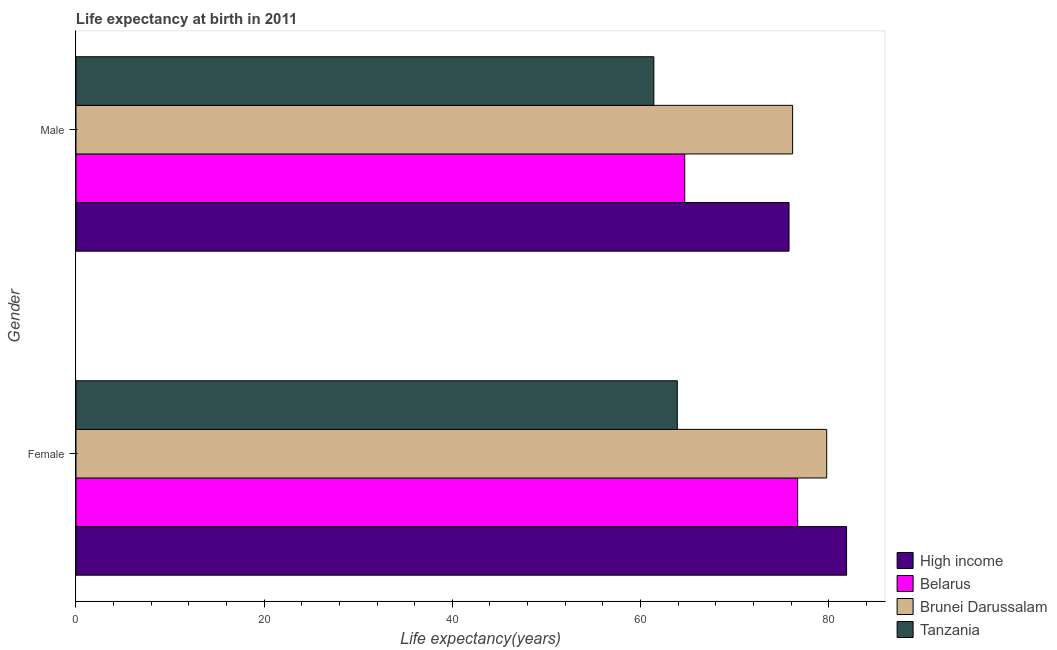How many different coloured bars are there?
Give a very brief answer. 4. How many groups of bars are there?
Offer a very short reply. 2. How many bars are there on the 1st tick from the top?
Provide a succinct answer. 4. What is the label of the 2nd group of bars from the top?
Your answer should be very brief. Female. What is the life expectancy(female) in Brunei Darussalam?
Make the answer very short. 79.79. Across all countries, what is the maximum life expectancy(female)?
Your answer should be very brief. 81.9. Across all countries, what is the minimum life expectancy(female)?
Offer a terse response. 63.91. In which country was the life expectancy(male) maximum?
Make the answer very short. Brunei Darussalam. In which country was the life expectancy(male) minimum?
Keep it short and to the point. Tanzania. What is the total life expectancy(female) in the graph?
Provide a short and direct response. 302.3. What is the difference between the life expectancy(male) in Brunei Darussalam and that in High income?
Your answer should be compact. 0.38. What is the difference between the life expectancy(female) in Belarus and the life expectancy(male) in Brunei Darussalam?
Ensure brevity in your answer.  0.53. What is the average life expectancy(female) per country?
Provide a succinct answer. 75.57. What is the difference between the life expectancy(female) and life expectancy(male) in Belarus?
Your answer should be compact. 12. In how many countries, is the life expectancy(female) greater than 20 years?
Offer a very short reply. 4. What is the ratio of the life expectancy(female) in High income to that in Tanzania?
Provide a short and direct response. 1.28. Is the life expectancy(female) in Brunei Darussalam less than that in Tanzania?
Provide a short and direct response. No. What does the 3rd bar from the top in Male represents?
Make the answer very short. Belarus. How many bars are there?
Provide a succinct answer. 8. How many countries are there in the graph?
Your answer should be compact. 4. Are the values on the major ticks of X-axis written in scientific E-notation?
Give a very brief answer. No. Where does the legend appear in the graph?
Offer a very short reply. Bottom right. What is the title of the graph?
Give a very brief answer. Life expectancy at birth in 2011. What is the label or title of the X-axis?
Provide a short and direct response. Life expectancy(years). What is the Life expectancy(years) of High income in Female?
Make the answer very short. 81.9. What is the Life expectancy(years) of Belarus in Female?
Ensure brevity in your answer.  76.7. What is the Life expectancy(years) of Brunei Darussalam in Female?
Your answer should be compact. 79.79. What is the Life expectancy(years) in Tanzania in Female?
Provide a short and direct response. 63.91. What is the Life expectancy(years) of High income in Male?
Make the answer very short. 75.78. What is the Life expectancy(years) in Belarus in Male?
Keep it short and to the point. 64.7. What is the Life expectancy(years) of Brunei Darussalam in Male?
Your response must be concise. 76.17. What is the Life expectancy(years) of Tanzania in Male?
Your answer should be compact. 61.42. Across all Gender, what is the maximum Life expectancy(years) in High income?
Your answer should be very brief. 81.9. Across all Gender, what is the maximum Life expectancy(years) in Belarus?
Give a very brief answer. 76.7. Across all Gender, what is the maximum Life expectancy(years) in Brunei Darussalam?
Your answer should be very brief. 79.79. Across all Gender, what is the maximum Life expectancy(years) in Tanzania?
Make the answer very short. 63.91. Across all Gender, what is the minimum Life expectancy(years) in High income?
Your answer should be compact. 75.78. Across all Gender, what is the minimum Life expectancy(years) in Belarus?
Ensure brevity in your answer.  64.7. Across all Gender, what is the minimum Life expectancy(years) in Brunei Darussalam?
Ensure brevity in your answer.  76.17. Across all Gender, what is the minimum Life expectancy(years) in Tanzania?
Provide a short and direct response. 61.42. What is the total Life expectancy(years) of High income in the graph?
Offer a very short reply. 157.68. What is the total Life expectancy(years) of Belarus in the graph?
Give a very brief answer. 141.4. What is the total Life expectancy(years) of Brunei Darussalam in the graph?
Your answer should be compact. 155.95. What is the total Life expectancy(years) in Tanzania in the graph?
Your response must be concise. 125.33. What is the difference between the Life expectancy(years) of High income in Female and that in Male?
Provide a short and direct response. 6.12. What is the difference between the Life expectancy(years) of Brunei Darussalam in Female and that in Male?
Your answer should be compact. 3.62. What is the difference between the Life expectancy(years) in Tanzania in Female and that in Male?
Ensure brevity in your answer.  2.49. What is the difference between the Life expectancy(years) of High income in Female and the Life expectancy(years) of Belarus in Male?
Keep it short and to the point. 17.2. What is the difference between the Life expectancy(years) of High income in Female and the Life expectancy(years) of Brunei Darussalam in Male?
Offer a terse response. 5.73. What is the difference between the Life expectancy(years) in High income in Female and the Life expectancy(years) in Tanzania in Male?
Your answer should be compact. 20.48. What is the difference between the Life expectancy(years) of Belarus in Female and the Life expectancy(years) of Brunei Darussalam in Male?
Your response must be concise. 0.54. What is the difference between the Life expectancy(years) in Belarus in Female and the Life expectancy(years) in Tanzania in Male?
Give a very brief answer. 15.28. What is the difference between the Life expectancy(years) in Brunei Darussalam in Female and the Life expectancy(years) in Tanzania in Male?
Offer a very short reply. 18.37. What is the average Life expectancy(years) of High income per Gender?
Your response must be concise. 78.84. What is the average Life expectancy(years) in Belarus per Gender?
Offer a very short reply. 70.7. What is the average Life expectancy(years) of Brunei Darussalam per Gender?
Keep it short and to the point. 77.98. What is the average Life expectancy(years) of Tanzania per Gender?
Offer a terse response. 62.66. What is the difference between the Life expectancy(years) of High income and Life expectancy(years) of Belarus in Female?
Provide a short and direct response. 5.2. What is the difference between the Life expectancy(years) in High income and Life expectancy(years) in Brunei Darussalam in Female?
Give a very brief answer. 2.11. What is the difference between the Life expectancy(years) in High income and Life expectancy(years) in Tanzania in Female?
Make the answer very short. 17.99. What is the difference between the Life expectancy(years) of Belarus and Life expectancy(years) of Brunei Darussalam in Female?
Your answer should be compact. -3.09. What is the difference between the Life expectancy(years) in Belarus and Life expectancy(years) in Tanzania in Female?
Provide a succinct answer. 12.79. What is the difference between the Life expectancy(years) in Brunei Darussalam and Life expectancy(years) in Tanzania in Female?
Provide a succinct answer. 15.88. What is the difference between the Life expectancy(years) of High income and Life expectancy(years) of Belarus in Male?
Give a very brief answer. 11.08. What is the difference between the Life expectancy(years) of High income and Life expectancy(years) of Brunei Darussalam in Male?
Offer a terse response. -0.38. What is the difference between the Life expectancy(years) in High income and Life expectancy(years) in Tanzania in Male?
Your response must be concise. 14.37. What is the difference between the Life expectancy(years) of Belarus and Life expectancy(years) of Brunei Darussalam in Male?
Offer a very short reply. -11.46. What is the difference between the Life expectancy(years) in Belarus and Life expectancy(years) in Tanzania in Male?
Offer a terse response. 3.28. What is the difference between the Life expectancy(years) of Brunei Darussalam and Life expectancy(years) of Tanzania in Male?
Your answer should be compact. 14.75. What is the ratio of the Life expectancy(years) in High income in Female to that in Male?
Keep it short and to the point. 1.08. What is the ratio of the Life expectancy(years) in Belarus in Female to that in Male?
Give a very brief answer. 1.19. What is the ratio of the Life expectancy(years) of Brunei Darussalam in Female to that in Male?
Provide a short and direct response. 1.05. What is the ratio of the Life expectancy(years) in Tanzania in Female to that in Male?
Offer a very short reply. 1.04. What is the difference between the highest and the second highest Life expectancy(years) in High income?
Your answer should be compact. 6.12. What is the difference between the highest and the second highest Life expectancy(years) in Belarus?
Make the answer very short. 12. What is the difference between the highest and the second highest Life expectancy(years) in Brunei Darussalam?
Keep it short and to the point. 3.62. What is the difference between the highest and the second highest Life expectancy(years) in Tanzania?
Provide a succinct answer. 2.49. What is the difference between the highest and the lowest Life expectancy(years) in High income?
Give a very brief answer. 6.12. What is the difference between the highest and the lowest Life expectancy(years) in Belarus?
Your answer should be very brief. 12. What is the difference between the highest and the lowest Life expectancy(years) in Brunei Darussalam?
Provide a short and direct response. 3.62. What is the difference between the highest and the lowest Life expectancy(years) of Tanzania?
Your answer should be very brief. 2.49. 